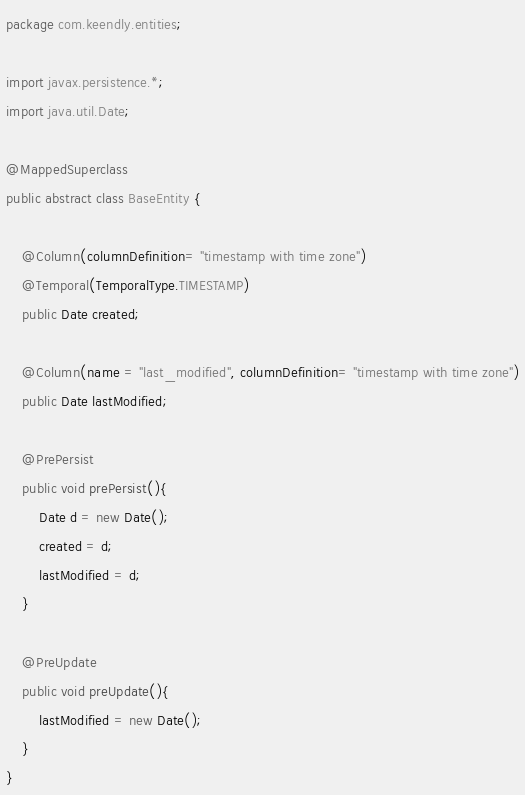Convert code to text. <code><loc_0><loc_0><loc_500><loc_500><_Java_>package com.keendly.entities;

import javax.persistence.*;
import java.util.Date;

@MappedSuperclass
public abstract class BaseEntity {

    @Column(columnDefinition= "timestamp with time zone")
    @Temporal(TemporalType.TIMESTAMP)
    public Date created;

    @Column(name = "last_modified", columnDefinition= "timestamp with time zone")
    public Date lastModified;

    @PrePersist
    public void prePersist(){
        Date d = new Date();
        created = d;
        lastModified = d;
    }

    @PreUpdate
    public void preUpdate(){
        lastModified = new Date();
    }
}
</code> 